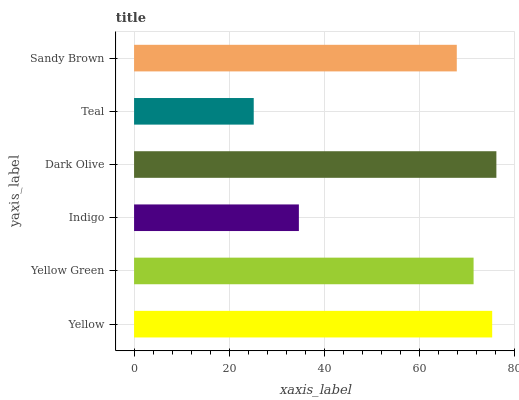Is Teal the minimum?
Answer yes or no. Yes. Is Dark Olive the maximum?
Answer yes or no. Yes. Is Yellow Green the minimum?
Answer yes or no. No. Is Yellow Green the maximum?
Answer yes or no. No. Is Yellow greater than Yellow Green?
Answer yes or no. Yes. Is Yellow Green less than Yellow?
Answer yes or no. Yes. Is Yellow Green greater than Yellow?
Answer yes or no. No. Is Yellow less than Yellow Green?
Answer yes or no. No. Is Yellow Green the high median?
Answer yes or no. Yes. Is Sandy Brown the low median?
Answer yes or no. Yes. Is Indigo the high median?
Answer yes or no. No. Is Yellow Green the low median?
Answer yes or no. No. 